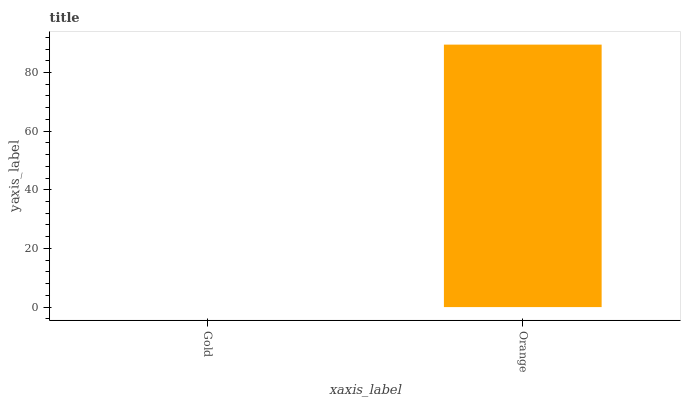Is Gold the minimum?
Answer yes or no. Yes. Is Orange the maximum?
Answer yes or no. Yes. Is Orange the minimum?
Answer yes or no. No. Is Orange greater than Gold?
Answer yes or no. Yes. Is Gold less than Orange?
Answer yes or no. Yes. Is Gold greater than Orange?
Answer yes or no. No. Is Orange less than Gold?
Answer yes or no. No. Is Orange the high median?
Answer yes or no. Yes. Is Gold the low median?
Answer yes or no. Yes. Is Gold the high median?
Answer yes or no. No. Is Orange the low median?
Answer yes or no. No. 